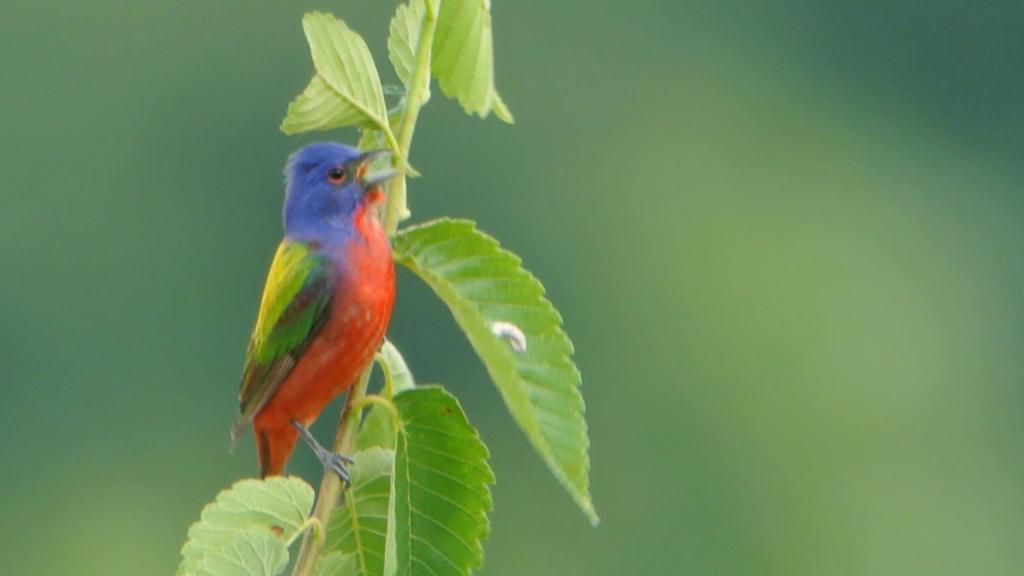What type of animal can be seen in the image? There is a bird in the image. Where is the bird located in the image? The bird is standing on the stem of a plant. How many kittens are sleeping on the bird's back in the image? There are no kittens present in the image, and the bird is not depicted as sleeping. 